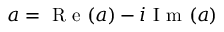Convert formula to latex. <formula><loc_0><loc_0><loc_500><loc_500>a = R e ( a ) - i I m ( a )</formula> 